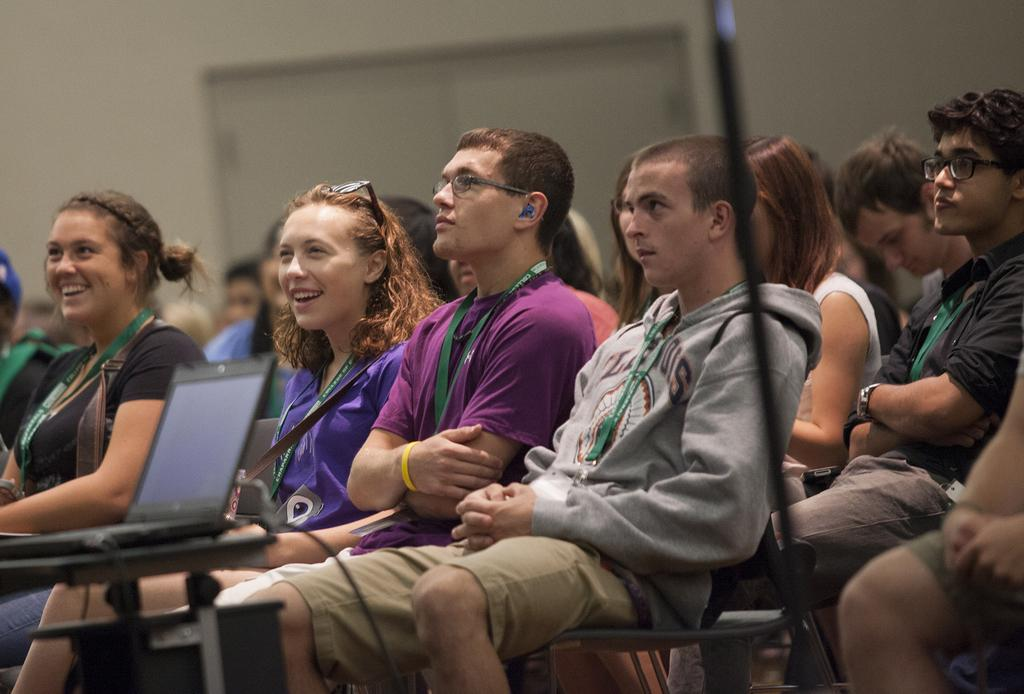What are the people in the image doing? The people in the image are sitting on chairs. What electronic device can be seen on a table in the image? There is a laptop on a table in the image. What can be seen in the background of the image? There is a wall visible in the background of the image. Where are the babies in the image? There are no babies present in the image. What type of animals can be seen at the zoo in the image? There is no zoo or animals present in the image. 